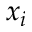Convert formula to latex. <formula><loc_0><loc_0><loc_500><loc_500>x _ { i }</formula> 